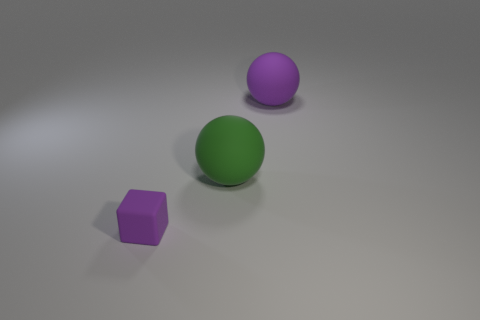What number of big objects have the same color as the tiny thing?
Give a very brief answer. 1. What shape is the tiny rubber thing?
Provide a short and direct response. Cube. What color is the object that is on the left side of the purple ball and behind the purple matte cube?
Ensure brevity in your answer.  Green. The large matte object that is to the left of the large purple sphere has what shape?
Your answer should be compact. Sphere. What is the color of the other rubber ball that is the same size as the purple ball?
Your answer should be very brief. Green. What size is the sphere in front of the big purple sphere?
Your answer should be compact. Large. The large thing that is the same color as the small rubber block is what shape?
Offer a very short reply. Sphere. The purple thing behind the small purple block left of the purple rubber thing right of the tiny purple rubber cube is what shape?
Your answer should be very brief. Sphere. How many other things are there of the same shape as the big green rubber object?
Offer a very short reply. 1. How many rubber objects are either small purple blocks or large purple balls?
Offer a very short reply. 2. 